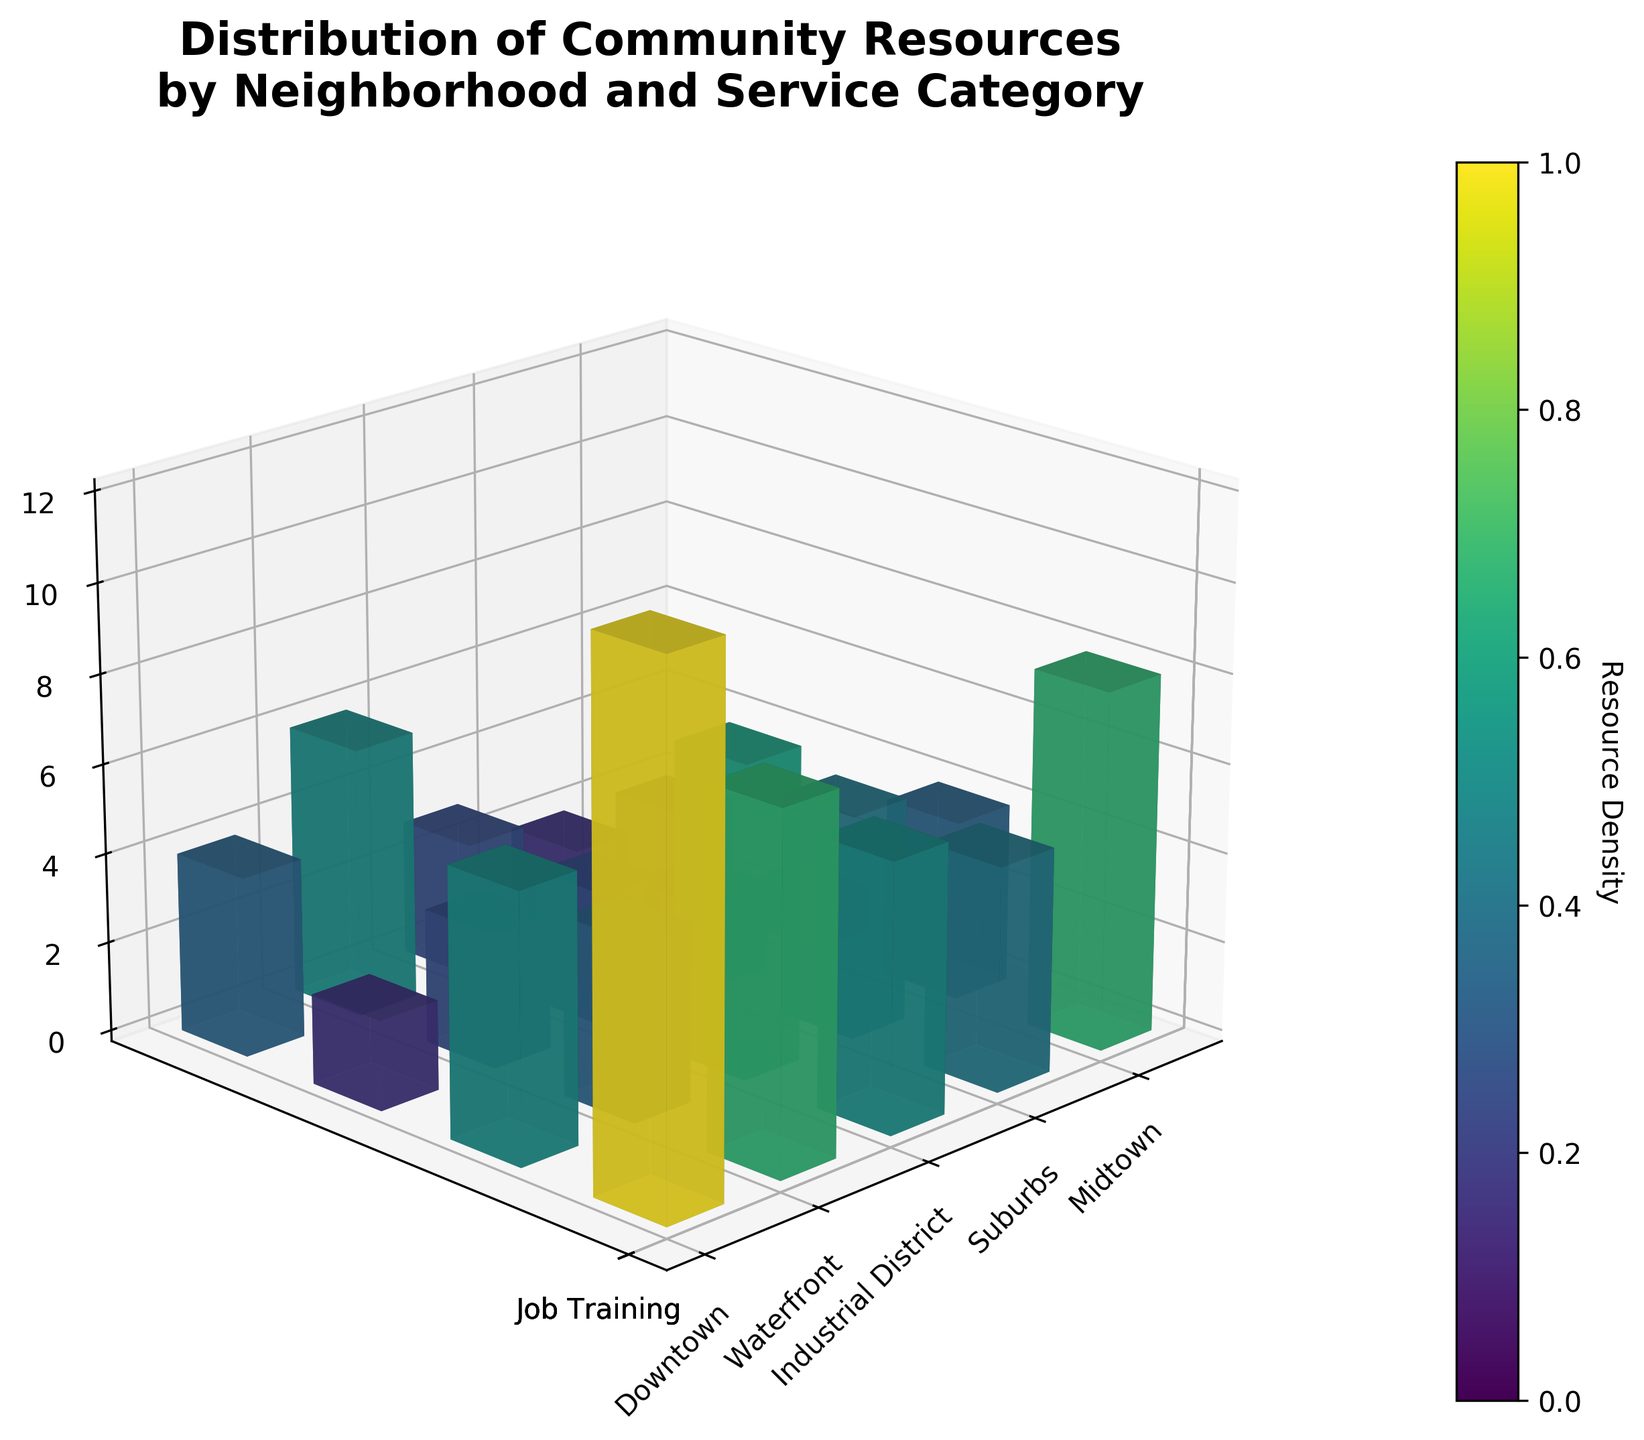What's the title of the figure? The title is usually at the top of the figure. In this case, it reads "Distribution of Community Resources by Neighborhood and Service Category".
Answer: Distribution of Community Resources by Neighborhood and Service Category Which neighborhood has the most resources for mental health services? From the plot, look at the bars corresponding to "Mental Health" for different neighborhoods. The tallest bar represents the highest number, which corresponds to Downtown.
Answer: Downtown How many resources are allocated to food banks in the Suburbs? Locate the bar for "Food Banks" in the Suburbs. The height of the bar indicates the number of resources, which is 4.
Answer: 4 What service category seems to have the fewest resources in the Industrial District? Look at all the bars in the Industrial District. The shortest bar, indicating the fewest resources, is for "Homeless Shelters".
Answer: Homeless Shelters Which service category has the highest number of resources in Midtown? Focus on the Midtown section of the plot and compare the heights of bars for different service categories. "Job Training" has the highest bar, indicating the most resources.
Answer: Job Training Compare the number of food bank resources between Downtown and Waterfront. Locate the "Food Banks" bars for both Downtown and Waterfront. Downtown has 8 resources, and Waterfront has 3. Downtown has 5 more resources than Waterfront.
Answer: Downtown has 5 more resources than Waterfront What is the total number of mental health resources across all neighborhoods? Sum the mental health resources: Downtown (12) + Midtown (8) + Suburbs (5) + Industrial District (3) + Waterfront (6) = 34.
Answer: 34 Which neighborhood has the least total resources across all service categories? Sum resources for each neighborhood: 
- Downtown (12+8+6+5)=31
- Midtown (8+6+4+7)=25
- Suburbs (5+4+2+3)=14
- Industrial District (3+2+1+4)=10
- Waterfront (6+3+2+2)=13 
Industrial District has the least, 10.
Answer: Industrial District Are job training resources more abundant in Downtown or Suburbs? Compare the heights of the bars for "Job Training" in both neighborhoods. Downtown has 5 and Suburbs have 3, so Downtown has more.
Answer: Downtown 